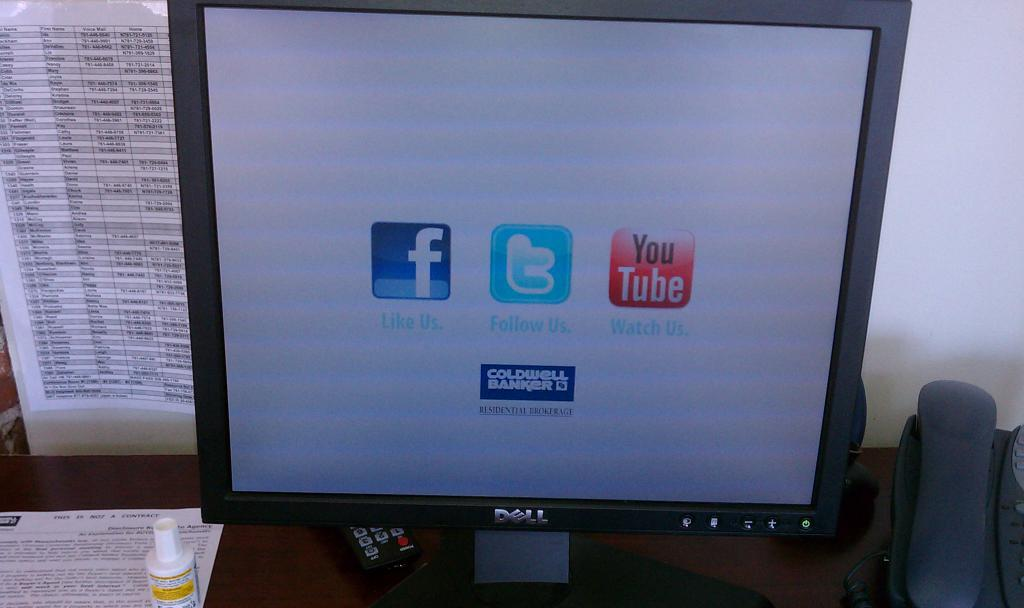<image>
Write a terse but informative summary of the picture. The screen of a dell monitor with logos for facebook and twitter. 